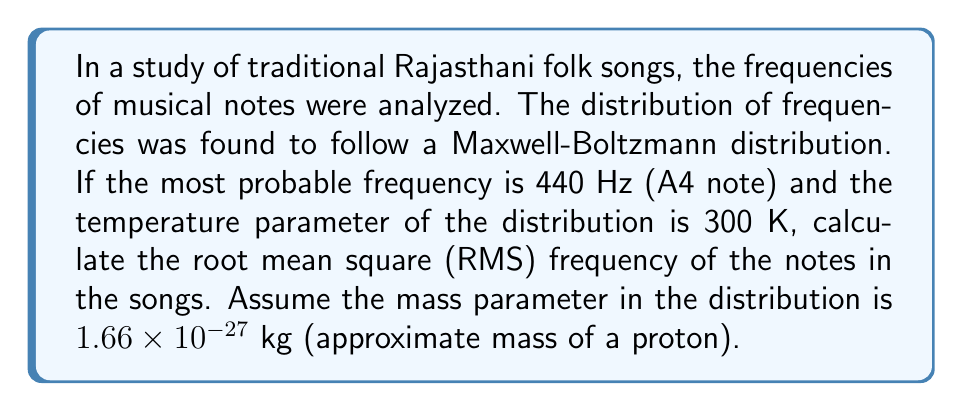Show me your answer to this math problem. To solve this problem, we'll follow these steps:

1) The Maxwell-Boltzmann distribution for frequencies can be written as:

   $$f(v) = \sqrt{\frac{2}{\pi}} \left(\frac{m}{k_BT}\right)^{3/2} v^2 e^{-\frac{mv^2}{2k_BT}}$$

   where $v$ is the frequency, $m$ is the mass parameter, $k_B$ is the Boltzmann constant, and $T$ is the temperature.

2) The most probable frequency $v_p$ is given by:

   $$v_p = \sqrt{\frac{2k_BT}{m}}$$

3) We're given that $v_p = 440$ Hz. Let's use this to find $k_B$:

   $$440 = \sqrt{\frac{2k_B(300)}{1.66 \times 10^{-27}}}$$
   $$k_B = \frac{440^2 \times 1.66 \times 10^{-27}}{2 \times 300} = 5.35 \times 10^{-23} \text{ J/K}$$

4) The root mean square (RMS) frequency $v_{rms}$ for a Maxwell-Boltzmann distribution is given by:

   $$v_{rms} = \sqrt{\frac{3k_BT}{m}}$$

5) Substituting the values:

   $$v_{rms} = \sqrt{\frac{3 \times 5.35 \times 10^{-23} \times 300}{1.66 \times 10^{-27}}}$$

6) Simplifying:

   $$v_{rms} = \sqrt{2.90 \times 10^5} \approx 539 \text{ Hz}$$
Answer: 539 Hz 